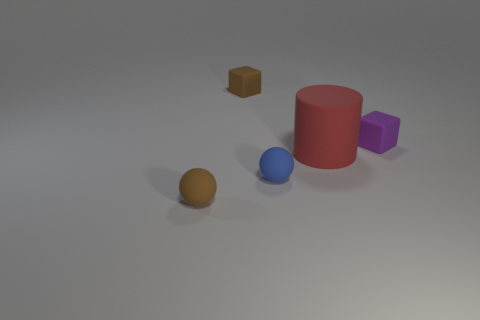Which object in the image looks the smoothest? The blue sphere looks the smoothest with its shiny and unblemished surface, indicative of a material like polished metal or glazed ceramic. 